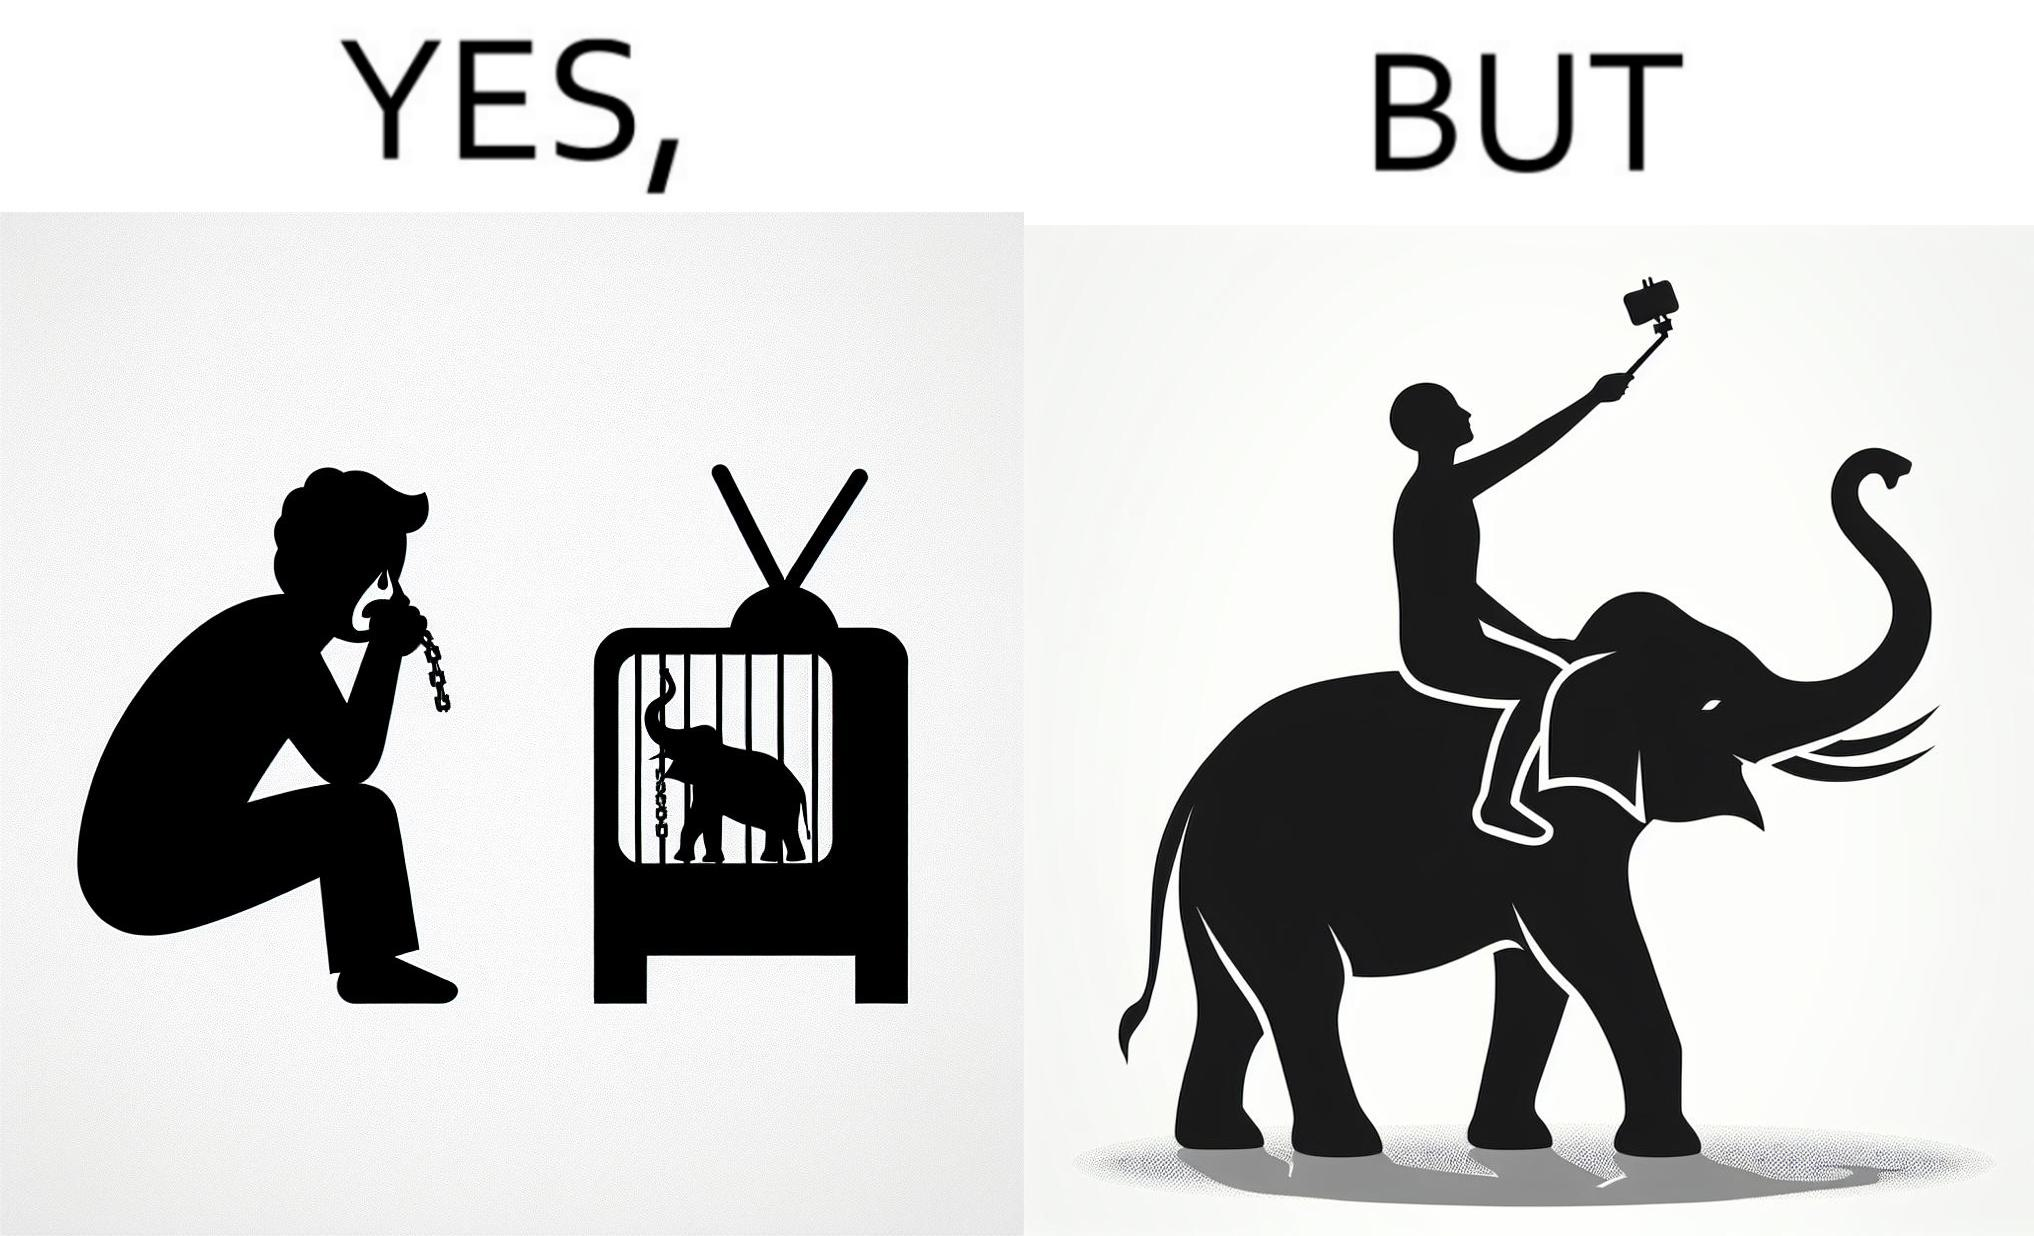Describe the contrast between the left and right parts of this image. In the left part of the image: a man crying on seeing an elephant being chained in a cage in a TV program In the right part of the image: a person riding an elephant while taking selfies 